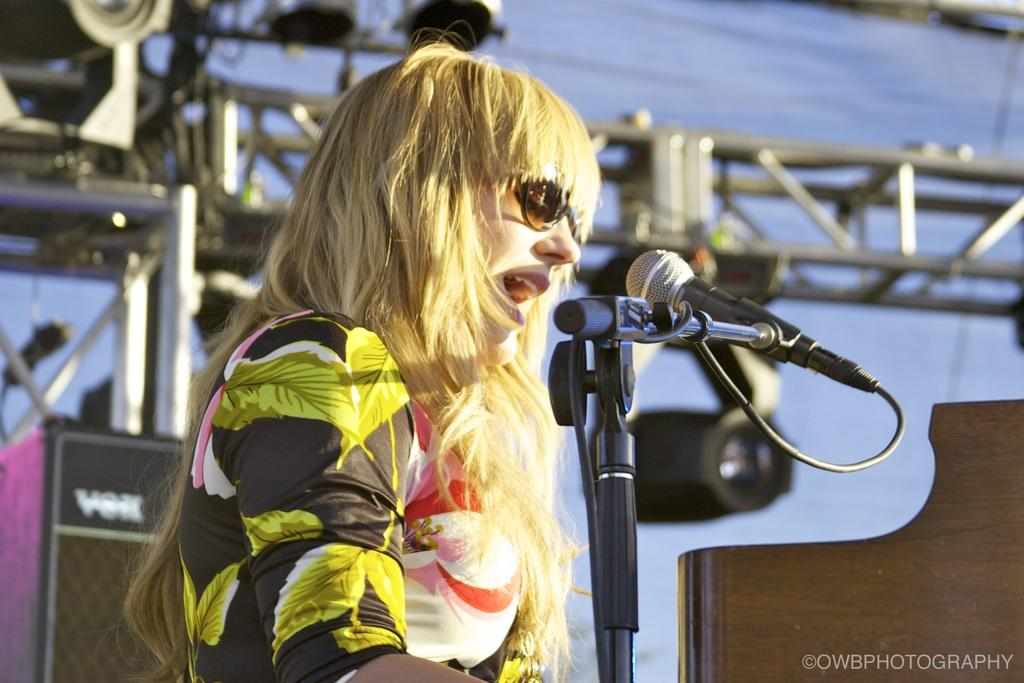What is the main subject of the image? There is a person in the image. What is the person doing in the image? The person is standing in front of a microphone. Can you describe the person's attire in the image? The person is wearing a black and green color dress. What can be seen in the background of the image? There are poles and lights visible in the background of the image. What type of machine can be seen in the background of the image? There is no machine visible in the background of the image; only poles and lights are present. Is the person's family visible in the image? There is no indication of the person's family in the image; only the person and the microphone are present. 